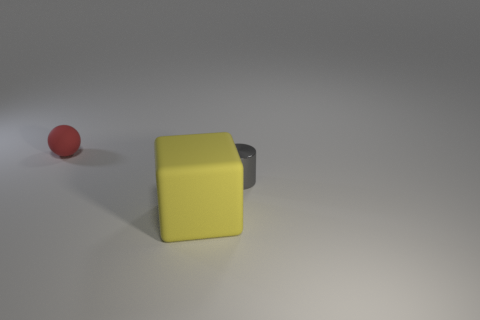Add 2 yellow rubber things. How many objects exist? 5 Add 3 big brown cubes. How many big brown cubes exist? 3 Subtract 0 brown blocks. How many objects are left? 3 Subtract all cylinders. How many objects are left? 2 Subtract all red cylinders. Subtract all green spheres. How many cylinders are left? 1 Subtract all blue blocks. How many blue balls are left? 0 Subtract all red rubber balls. Subtract all gray cylinders. How many objects are left? 1 Add 1 gray things. How many gray things are left? 2 